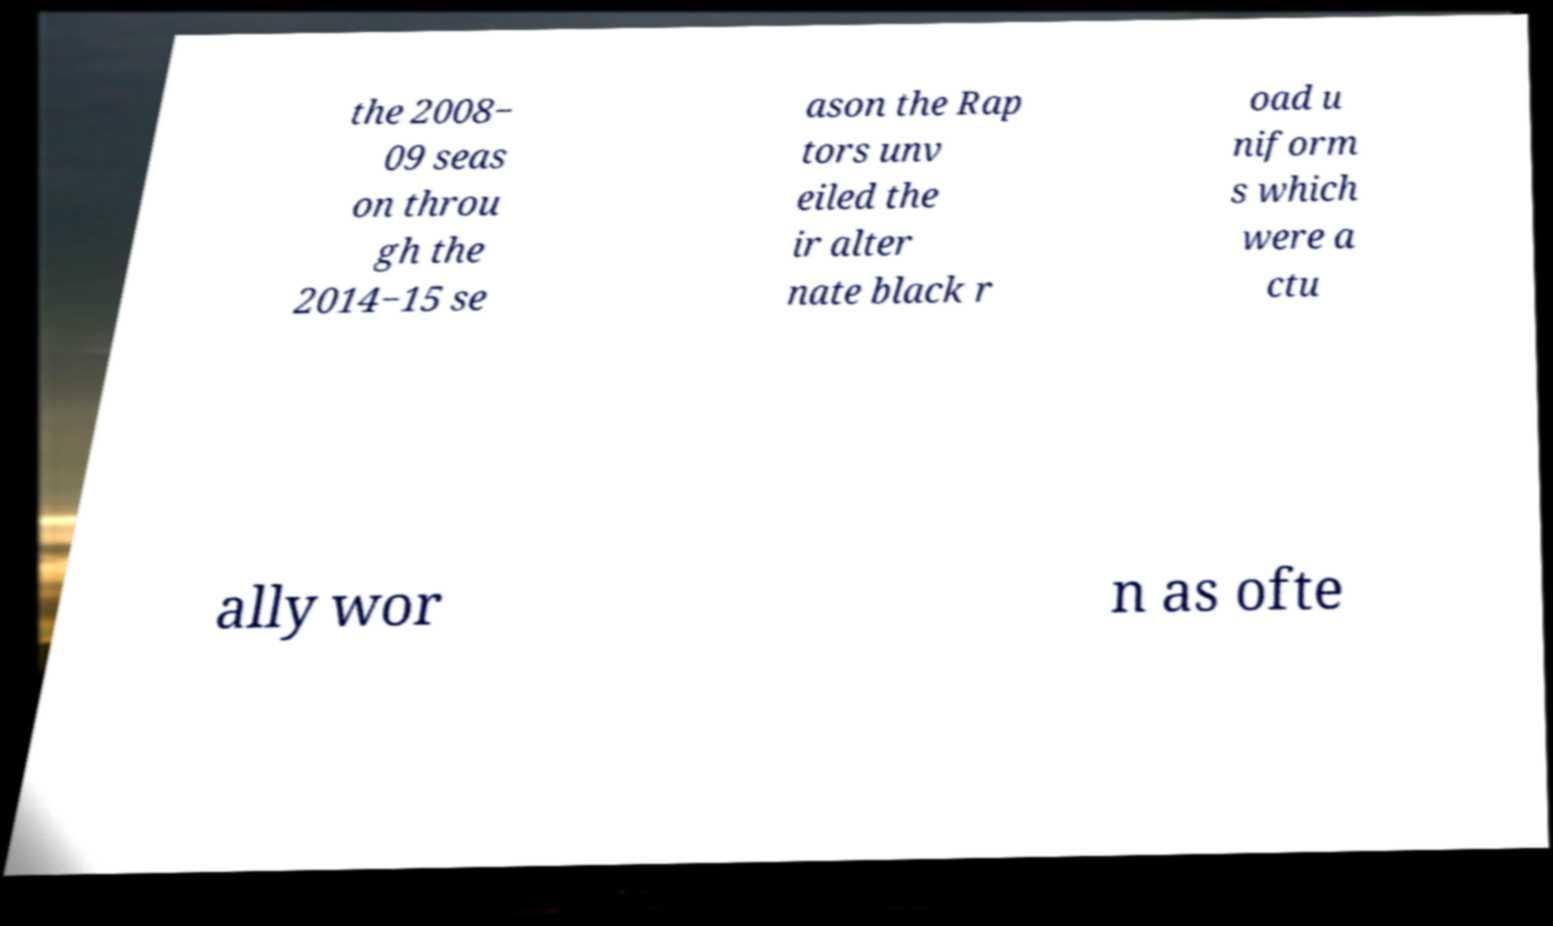Could you extract and type out the text from this image? the 2008− 09 seas on throu gh the 2014−15 se ason the Rap tors unv eiled the ir alter nate black r oad u niform s which were a ctu ally wor n as ofte 